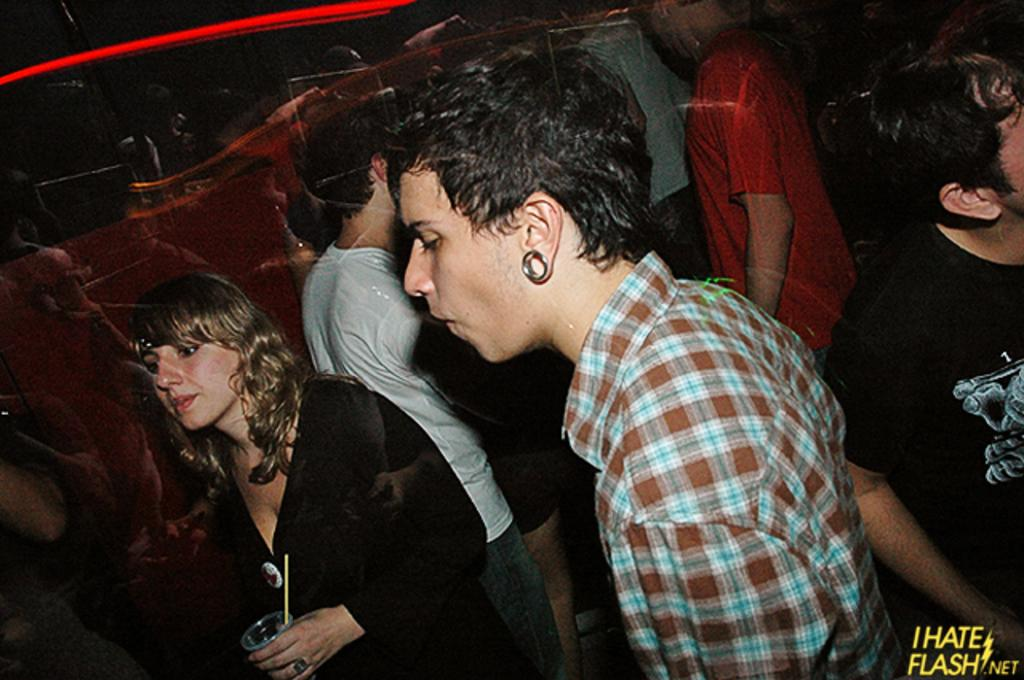Who can be seen in the image? There are people in the image. Can you describe the lady on the left side of the image? The lady is standing on the left side of the image, and she is holding a glass. What can be seen in the image that provides illumination? There is a light in the image. What type of wine is the lady drinking in the image? There is no wine present in the image, and the lady is holding a glass, not drinking from it. 